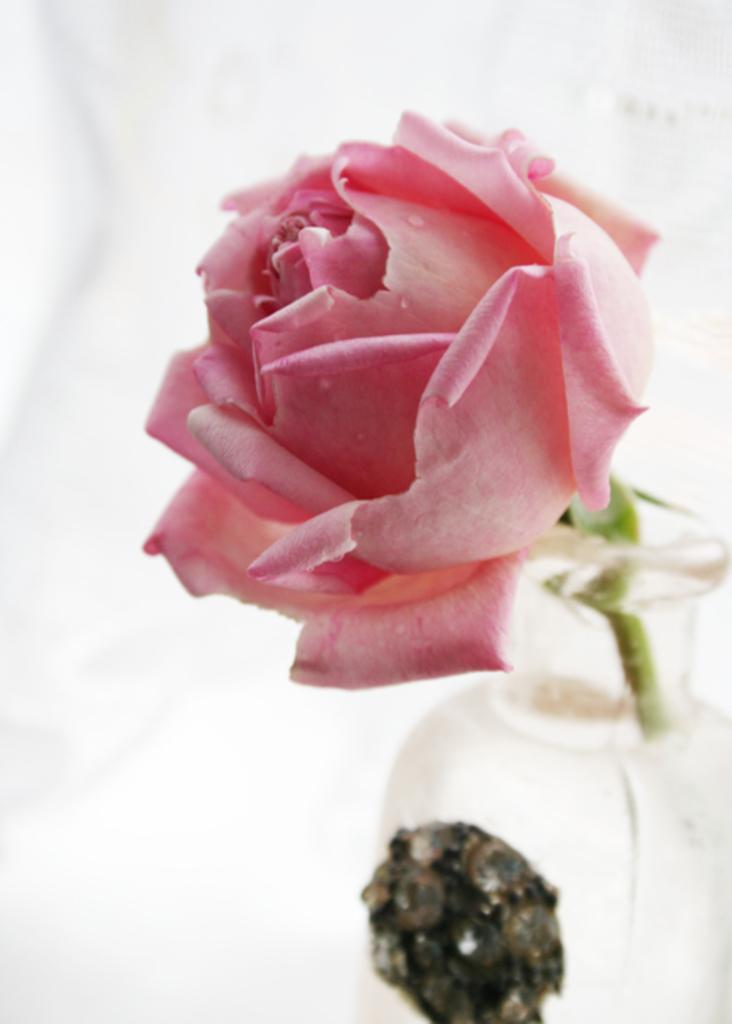What is the main object in the image? There is a flower vase in the image. What color is the flower in the vase? The flower is pink. What color is the background of the image? The background of the image is white. What type of juice is being served in the carriage in the image? There is no carriage or juice present in the image; it features a flower vase with a pink flower against a white background. 